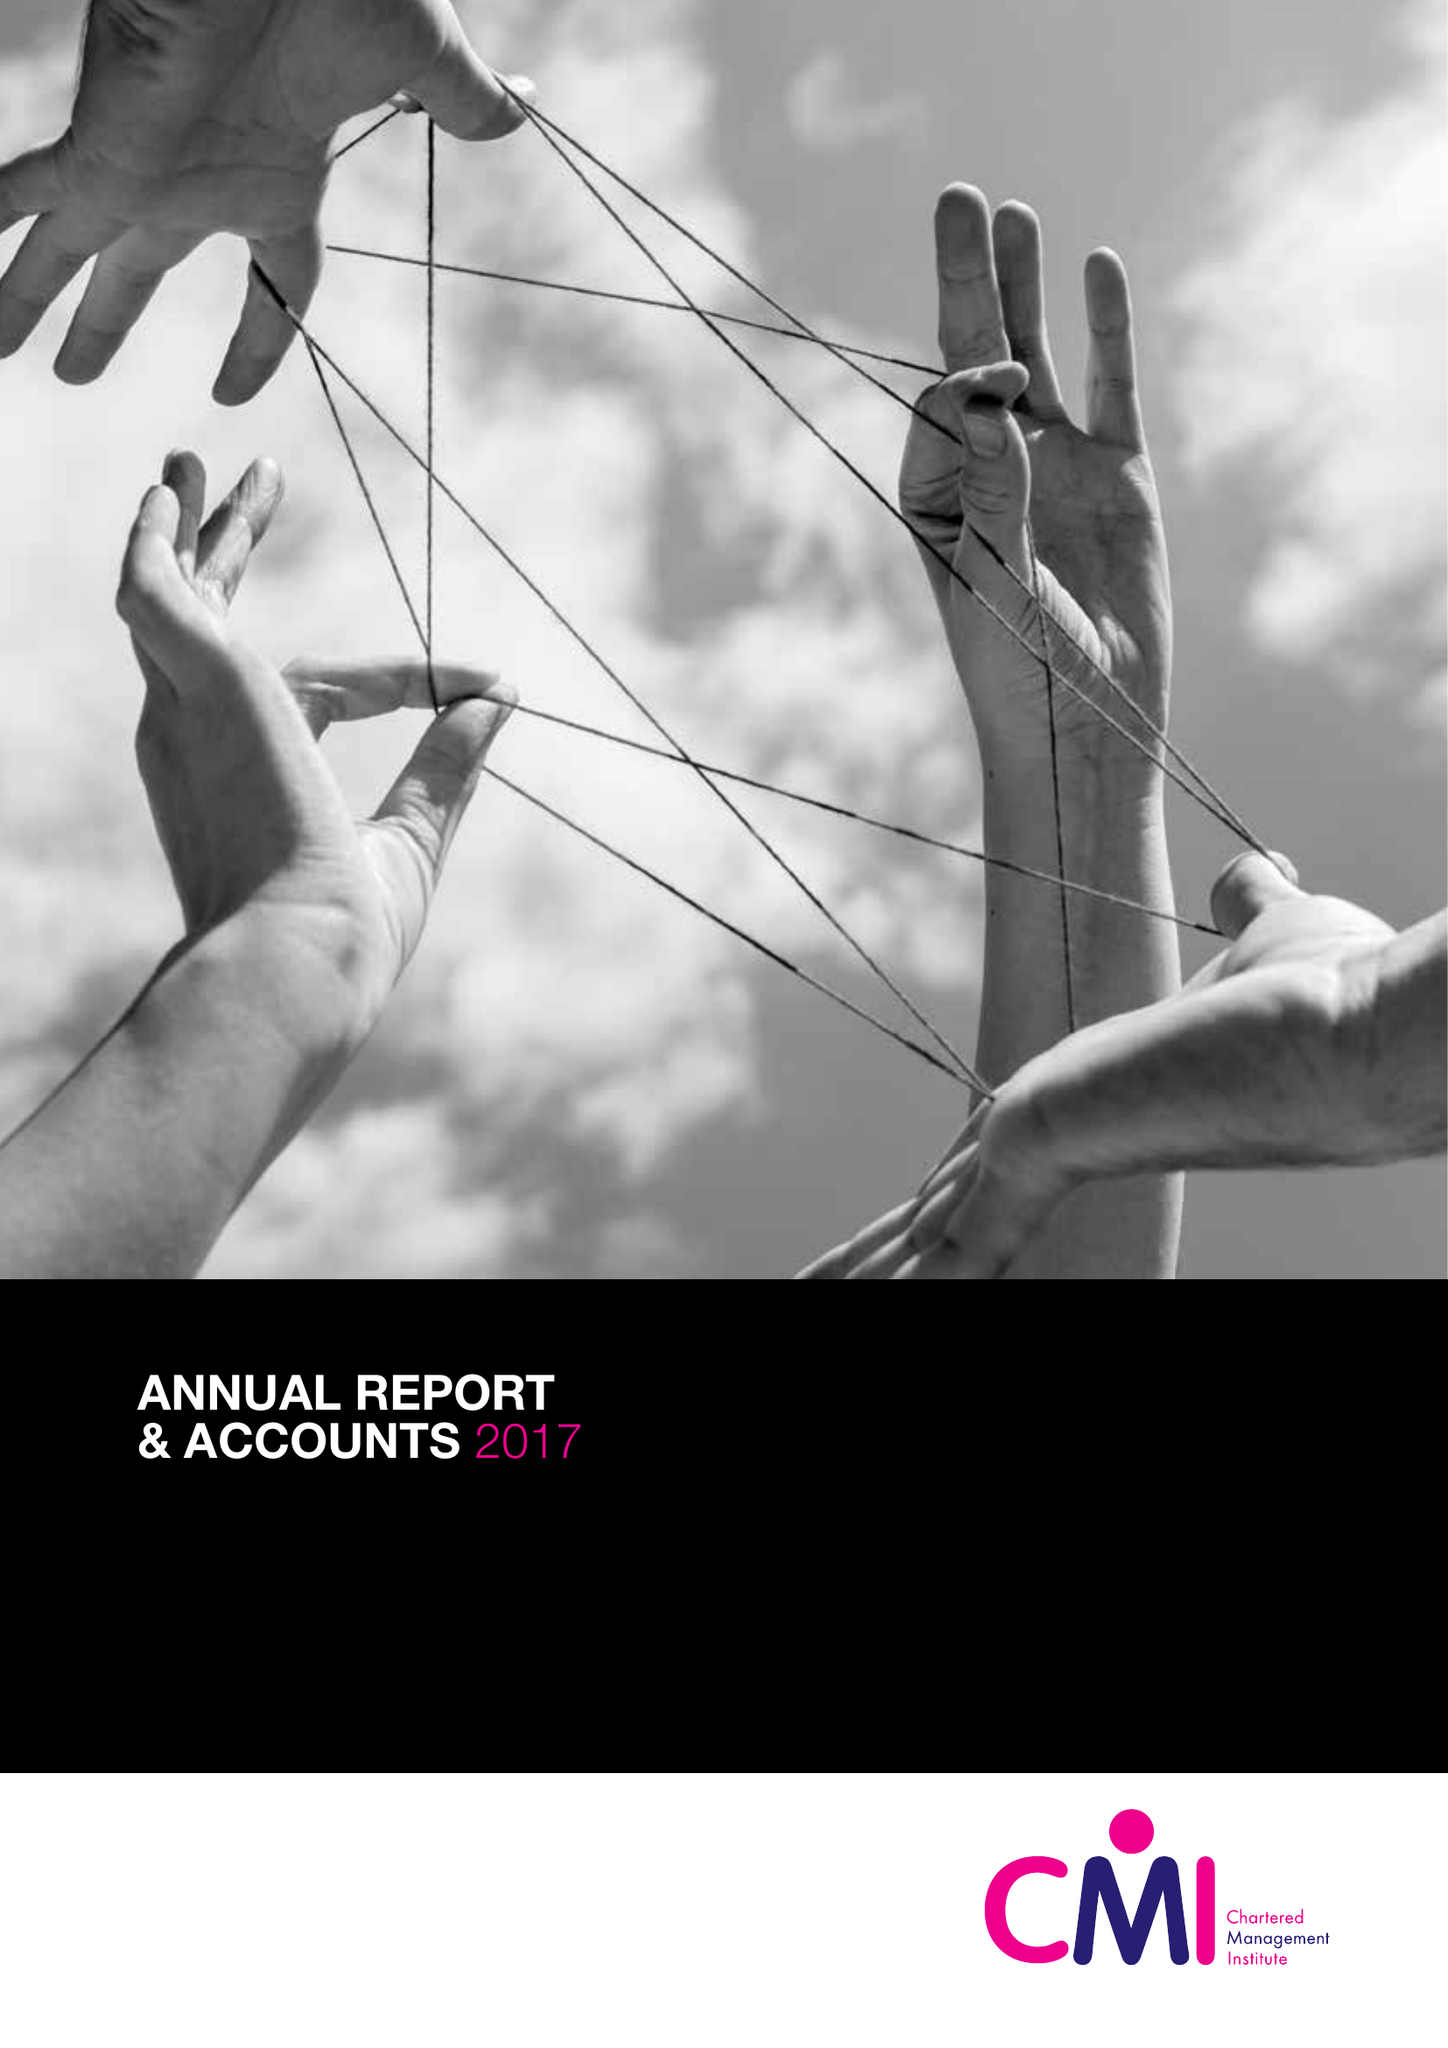What is the value for the charity_number?
Answer the question using a single word or phrase. 1091035 